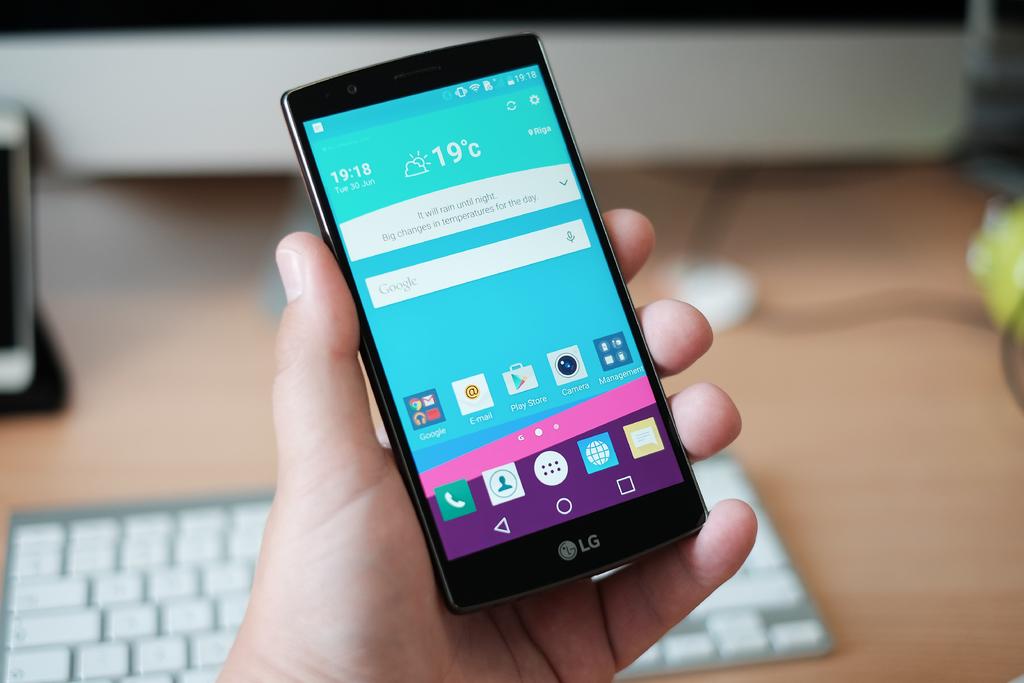What temperature does the phone say it is?
Your response must be concise. 19. What type of phone is this?
Your answer should be compact. Lg. 